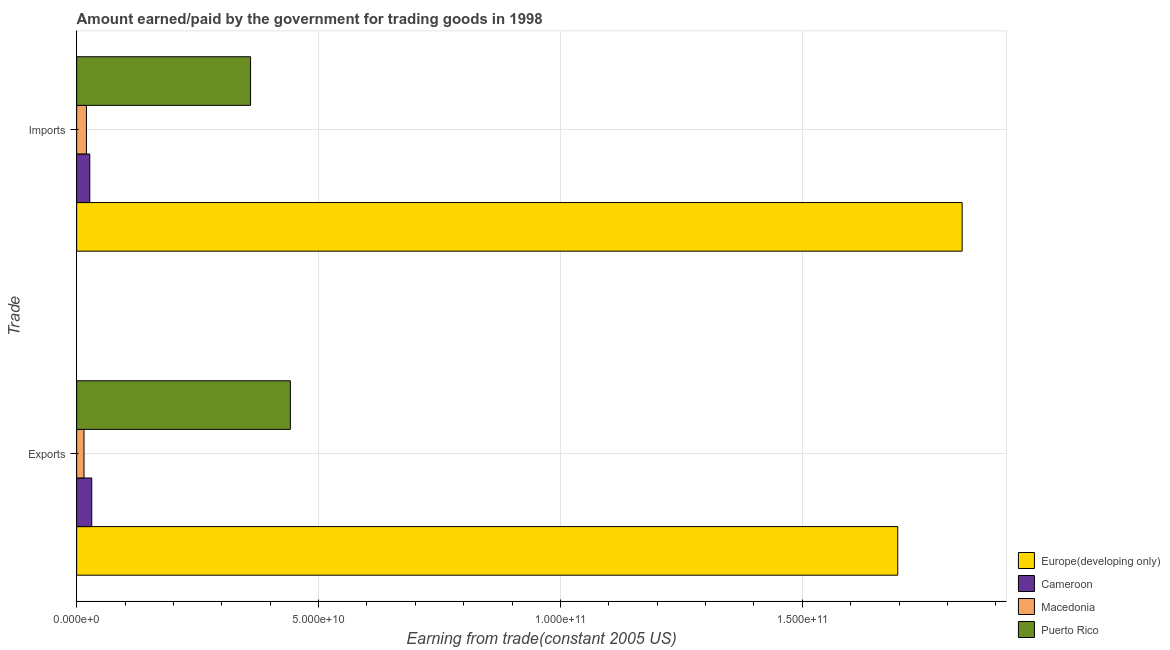How many different coloured bars are there?
Your answer should be very brief. 4. How many groups of bars are there?
Provide a short and direct response. 2. How many bars are there on the 2nd tick from the top?
Keep it short and to the point. 4. How many bars are there on the 2nd tick from the bottom?
Your answer should be compact. 4. What is the label of the 2nd group of bars from the top?
Offer a terse response. Exports. What is the amount paid for imports in Puerto Rico?
Offer a terse response. 3.59e+1. Across all countries, what is the maximum amount paid for imports?
Provide a short and direct response. 1.83e+11. Across all countries, what is the minimum amount paid for imports?
Provide a short and direct response. 2.02e+09. In which country was the amount paid for imports maximum?
Give a very brief answer. Europe(developing only). In which country was the amount earned from exports minimum?
Keep it short and to the point. Macedonia. What is the total amount earned from exports in the graph?
Your response must be concise. 2.19e+11. What is the difference between the amount paid for imports in Macedonia and that in Puerto Rico?
Provide a short and direct response. -3.39e+1. What is the difference between the amount earned from exports in Macedonia and the amount paid for imports in Europe(developing only)?
Offer a terse response. -1.82e+11. What is the average amount paid for imports per country?
Keep it short and to the point. 5.59e+1. What is the difference between the amount paid for imports and amount earned from exports in Macedonia?
Offer a very short reply. 5.03e+08. In how many countries, is the amount paid for imports greater than 160000000000 US$?
Your answer should be very brief. 1. What is the ratio of the amount earned from exports in Puerto Rico to that in Europe(developing only)?
Ensure brevity in your answer.  0.26. In how many countries, is the amount earned from exports greater than the average amount earned from exports taken over all countries?
Your answer should be very brief. 1. What does the 4th bar from the top in Exports represents?
Your answer should be compact. Europe(developing only). What does the 1st bar from the bottom in Exports represents?
Provide a short and direct response. Europe(developing only). How many bars are there?
Your response must be concise. 8. What is the difference between two consecutive major ticks on the X-axis?
Ensure brevity in your answer.  5.00e+1. Where does the legend appear in the graph?
Offer a very short reply. Bottom right. What is the title of the graph?
Offer a very short reply. Amount earned/paid by the government for trading goods in 1998. What is the label or title of the X-axis?
Provide a succinct answer. Earning from trade(constant 2005 US). What is the label or title of the Y-axis?
Give a very brief answer. Trade. What is the Earning from trade(constant 2005 US) in Europe(developing only) in Exports?
Keep it short and to the point. 1.70e+11. What is the Earning from trade(constant 2005 US) in Cameroon in Exports?
Keep it short and to the point. 3.12e+09. What is the Earning from trade(constant 2005 US) of Macedonia in Exports?
Provide a succinct answer. 1.52e+09. What is the Earning from trade(constant 2005 US) of Puerto Rico in Exports?
Offer a very short reply. 4.42e+1. What is the Earning from trade(constant 2005 US) in Europe(developing only) in Imports?
Keep it short and to the point. 1.83e+11. What is the Earning from trade(constant 2005 US) in Cameroon in Imports?
Make the answer very short. 2.71e+09. What is the Earning from trade(constant 2005 US) in Macedonia in Imports?
Your response must be concise. 2.02e+09. What is the Earning from trade(constant 2005 US) in Puerto Rico in Imports?
Give a very brief answer. 3.59e+1. Across all Trade, what is the maximum Earning from trade(constant 2005 US) in Europe(developing only)?
Give a very brief answer. 1.83e+11. Across all Trade, what is the maximum Earning from trade(constant 2005 US) of Cameroon?
Make the answer very short. 3.12e+09. Across all Trade, what is the maximum Earning from trade(constant 2005 US) of Macedonia?
Your response must be concise. 2.02e+09. Across all Trade, what is the maximum Earning from trade(constant 2005 US) of Puerto Rico?
Offer a very short reply. 4.42e+1. Across all Trade, what is the minimum Earning from trade(constant 2005 US) in Europe(developing only)?
Make the answer very short. 1.70e+11. Across all Trade, what is the minimum Earning from trade(constant 2005 US) of Cameroon?
Ensure brevity in your answer.  2.71e+09. Across all Trade, what is the minimum Earning from trade(constant 2005 US) in Macedonia?
Offer a very short reply. 1.52e+09. Across all Trade, what is the minimum Earning from trade(constant 2005 US) of Puerto Rico?
Provide a succinct answer. 3.59e+1. What is the total Earning from trade(constant 2005 US) of Europe(developing only) in the graph?
Offer a very short reply. 3.53e+11. What is the total Earning from trade(constant 2005 US) of Cameroon in the graph?
Ensure brevity in your answer.  5.83e+09. What is the total Earning from trade(constant 2005 US) of Macedonia in the graph?
Ensure brevity in your answer.  3.54e+09. What is the total Earning from trade(constant 2005 US) of Puerto Rico in the graph?
Your answer should be very brief. 8.01e+1. What is the difference between the Earning from trade(constant 2005 US) of Europe(developing only) in Exports and that in Imports?
Provide a succinct answer. -1.33e+1. What is the difference between the Earning from trade(constant 2005 US) of Cameroon in Exports and that in Imports?
Provide a short and direct response. 4.08e+08. What is the difference between the Earning from trade(constant 2005 US) of Macedonia in Exports and that in Imports?
Your response must be concise. -5.03e+08. What is the difference between the Earning from trade(constant 2005 US) in Puerto Rico in Exports and that in Imports?
Provide a succinct answer. 8.23e+09. What is the difference between the Earning from trade(constant 2005 US) in Europe(developing only) in Exports and the Earning from trade(constant 2005 US) in Cameroon in Imports?
Provide a short and direct response. 1.67e+11. What is the difference between the Earning from trade(constant 2005 US) in Europe(developing only) in Exports and the Earning from trade(constant 2005 US) in Macedonia in Imports?
Provide a short and direct response. 1.68e+11. What is the difference between the Earning from trade(constant 2005 US) of Europe(developing only) in Exports and the Earning from trade(constant 2005 US) of Puerto Rico in Imports?
Offer a very short reply. 1.34e+11. What is the difference between the Earning from trade(constant 2005 US) of Cameroon in Exports and the Earning from trade(constant 2005 US) of Macedonia in Imports?
Provide a succinct answer. 1.10e+09. What is the difference between the Earning from trade(constant 2005 US) in Cameroon in Exports and the Earning from trade(constant 2005 US) in Puerto Rico in Imports?
Offer a very short reply. -3.28e+1. What is the difference between the Earning from trade(constant 2005 US) of Macedonia in Exports and the Earning from trade(constant 2005 US) of Puerto Rico in Imports?
Ensure brevity in your answer.  -3.44e+1. What is the average Earning from trade(constant 2005 US) of Europe(developing only) per Trade?
Your answer should be very brief. 1.76e+11. What is the average Earning from trade(constant 2005 US) in Cameroon per Trade?
Keep it short and to the point. 2.92e+09. What is the average Earning from trade(constant 2005 US) in Macedonia per Trade?
Provide a short and direct response. 1.77e+09. What is the average Earning from trade(constant 2005 US) of Puerto Rico per Trade?
Your answer should be very brief. 4.01e+1. What is the difference between the Earning from trade(constant 2005 US) in Europe(developing only) and Earning from trade(constant 2005 US) in Cameroon in Exports?
Ensure brevity in your answer.  1.67e+11. What is the difference between the Earning from trade(constant 2005 US) of Europe(developing only) and Earning from trade(constant 2005 US) of Macedonia in Exports?
Keep it short and to the point. 1.68e+11. What is the difference between the Earning from trade(constant 2005 US) in Europe(developing only) and Earning from trade(constant 2005 US) in Puerto Rico in Exports?
Provide a short and direct response. 1.26e+11. What is the difference between the Earning from trade(constant 2005 US) of Cameroon and Earning from trade(constant 2005 US) of Macedonia in Exports?
Your answer should be very brief. 1.60e+09. What is the difference between the Earning from trade(constant 2005 US) of Cameroon and Earning from trade(constant 2005 US) of Puerto Rico in Exports?
Make the answer very short. -4.11e+1. What is the difference between the Earning from trade(constant 2005 US) of Macedonia and Earning from trade(constant 2005 US) of Puerto Rico in Exports?
Your answer should be very brief. -4.27e+1. What is the difference between the Earning from trade(constant 2005 US) of Europe(developing only) and Earning from trade(constant 2005 US) of Cameroon in Imports?
Your answer should be very brief. 1.80e+11. What is the difference between the Earning from trade(constant 2005 US) in Europe(developing only) and Earning from trade(constant 2005 US) in Macedonia in Imports?
Give a very brief answer. 1.81e+11. What is the difference between the Earning from trade(constant 2005 US) of Europe(developing only) and Earning from trade(constant 2005 US) of Puerto Rico in Imports?
Give a very brief answer. 1.47e+11. What is the difference between the Earning from trade(constant 2005 US) in Cameroon and Earning from trade(constant 2005 US) in Macedonia in Imports?
Your answer should be compact. 6.90e+08. What is the difference between the Earning from trade(constant 2005 US) of Cameroon and Earning from trade(constant 2005 US) of Puerto Rico in Imports?
Provide a short and direct response. -3.32e+1. What is the difference between the Earning from trade(constant 2005 US) in Macedonia and Earning from trade(constant 2005 US) in Puerto Rico in Imports?
Offer a very short reply. -3.39e+1. What is the ratio of the Earning from trade(constant 2005 US) in Europe(developing only) in Exports to that in Imports?
Your answer should be compact. 0.93. What is the ratio of the Earning from trade(constant 2005 US) in Cameroon in Exports to that in Imports?
Provide a short and direct response. 1.15. What is the ratio of the Earning from trade(constant 2005 US) in Macedonia in Exports to that in Imports?
Keep it short and to the point. 0.75. What is the ratio of the Earning from trade(constant 2005 US) in Puerto Rico in Exports to that in Imports?
Provide a short and direct response. 1.23. What is the difference between the highest and the second highest Earning from trade(constant 2005 US) of Europe(developing only)?
Offer a terse response. 1.33e+1. What is the difference between the highest and the second highest Earning from trade(constant 2005 US) of Cameroon?
Offer a very short reply. 4.08e+08. What is the difference between the highest and the second highest Earning from trade(constant 2005 US) of Macedonia?
Your response must be concise. 5.03e+08. What is the difference between the highest and the second highest Earning from trade(constant 2005 US) in Puerto Rico?
Your answer should be compact. 8.23e+09. What is the difference between the highest and the lowest Earning from trade(constant 2005 US) of Europe(developing only)?
Your answer should be compact. 1.33e+1. What is the difference between the highest and the lowest Earning from trade(constant 2005 US) in Cameroon?
Offer a terse response. 4.08e+08. What is the difference between the highest and the lowest Earning from trade(constant 2005 US) of Macedonia?
Ensure brevity in your answer.  5.03e+08. What is the difference between the highest and the lowest Earning from trade(constant 2005 US) of Puerto Rico?
Your answer should be very brief. 8.23e+09. 